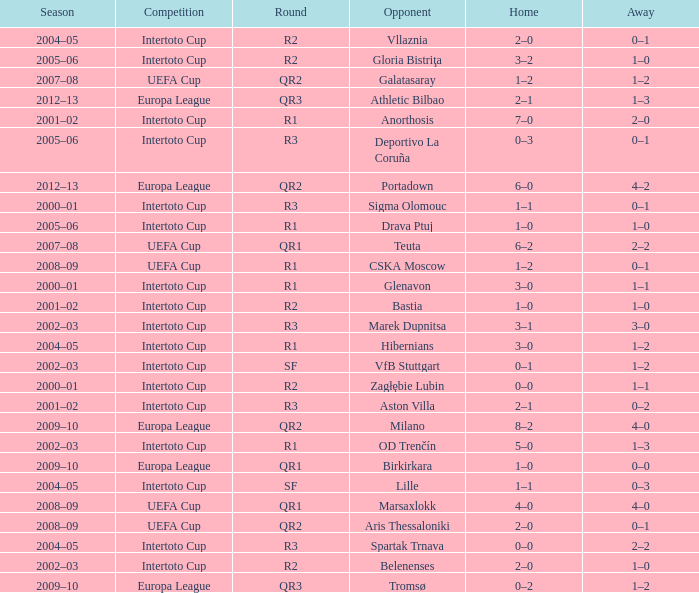What is the home score with marek dupnitsa as opponent? 3–1. 